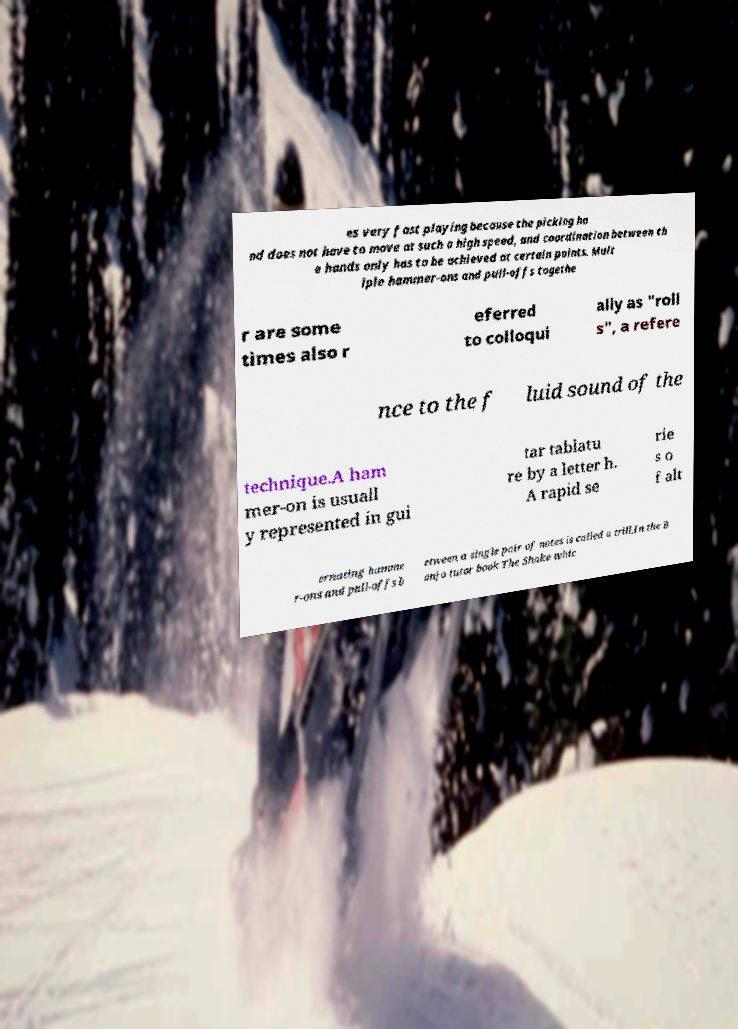There's text embedded in this image that I need extracted. Can you transcribe it verbatim? es very fast playing because the picking ha nd does not have to move at such a high speed, and coordination between th e hands only has to be achieved at certain points. Mult iple hammer-ons and pull-offs togethe r are some times also r eferred to colloqui ally as "roll s", a refere nce to the f luid sound of the technique.A ham mer-on is usuall y represented in gui tar tablatu re by a letter h. A rapid se rie s o f alt ernating hamme r-ons and pull-offs b etween a single pair of notes is called a trill.In the B anjo tutor book The Shake whic 